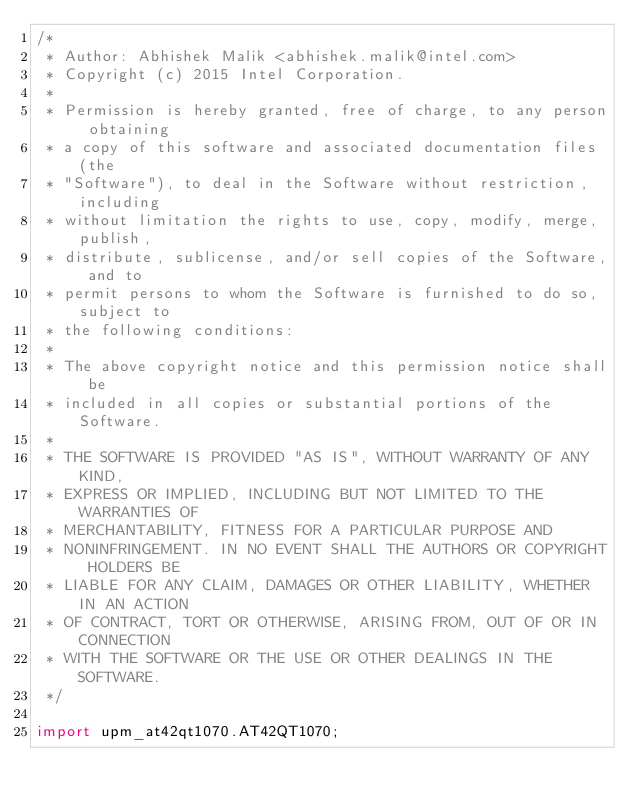<code> <loc_0><loc_0><loc_500><loc_500><_Java_>/*
 * Author: Abhishek Malik <abhishek.malik@intel.com>
 * Copyright (c) 2015 Intel Corporation.
 *
 * Permission is hereby granted, free of charge, to any person obtaining
 * a copy of this software and associated documentation files (the
 * "Software"), to deal in the Software without restriction, including
 * without limitation the rights to use, copy, modify, merge, publish,
 * distribute, sublicense, and/or sell copies of the Software, and to
 * permit persons to whom the Software is furnished to do so, subject to
 * the following conditions:
 *
 * The above copyright notice and this permission notice shall be
 * included in all copies or substantial portions of the Software.
 *
 * THE SOFTWARE IS PROVIDED "AS IS", WITHOUT WARRANTY OF ANY KIND,
 * EXPRESS OR IMPLIED, INCLUDING BUT NOT LIMITED TO THE WARRANTIES OF
 * MERCHANTABILITY, FITNESS FOR A PARTICULAR PURPOSE AND
 * NONINFRINGEMENT. IN NO EVENT SHALL THE AUTHORS OR COPYRIGHT HOLDERS BE
 * LIABLE FOR ANY CLAIM, DAMAGES OR OTHER LIABILITY, WHETHER IN AN ACTION
 * OF CONTRACT, TORT OR OTHERWISE, ARISING FROM, OUT OF OR IN CONNECTION
 * WITH THE SOFTWARE OR THE USE OR OTHER DEALINGS IN THE SOFTWARE.
 */

import upm_at42qt1070.AT42QT1070;
</code> 